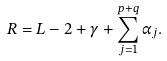<formula> <loc_0><loc_0><loc_500><loc_500>R = L - 2 + \gamma + \sum _ { j = 1 } ^ { p + q } \alpha _ { j } .</formula> 